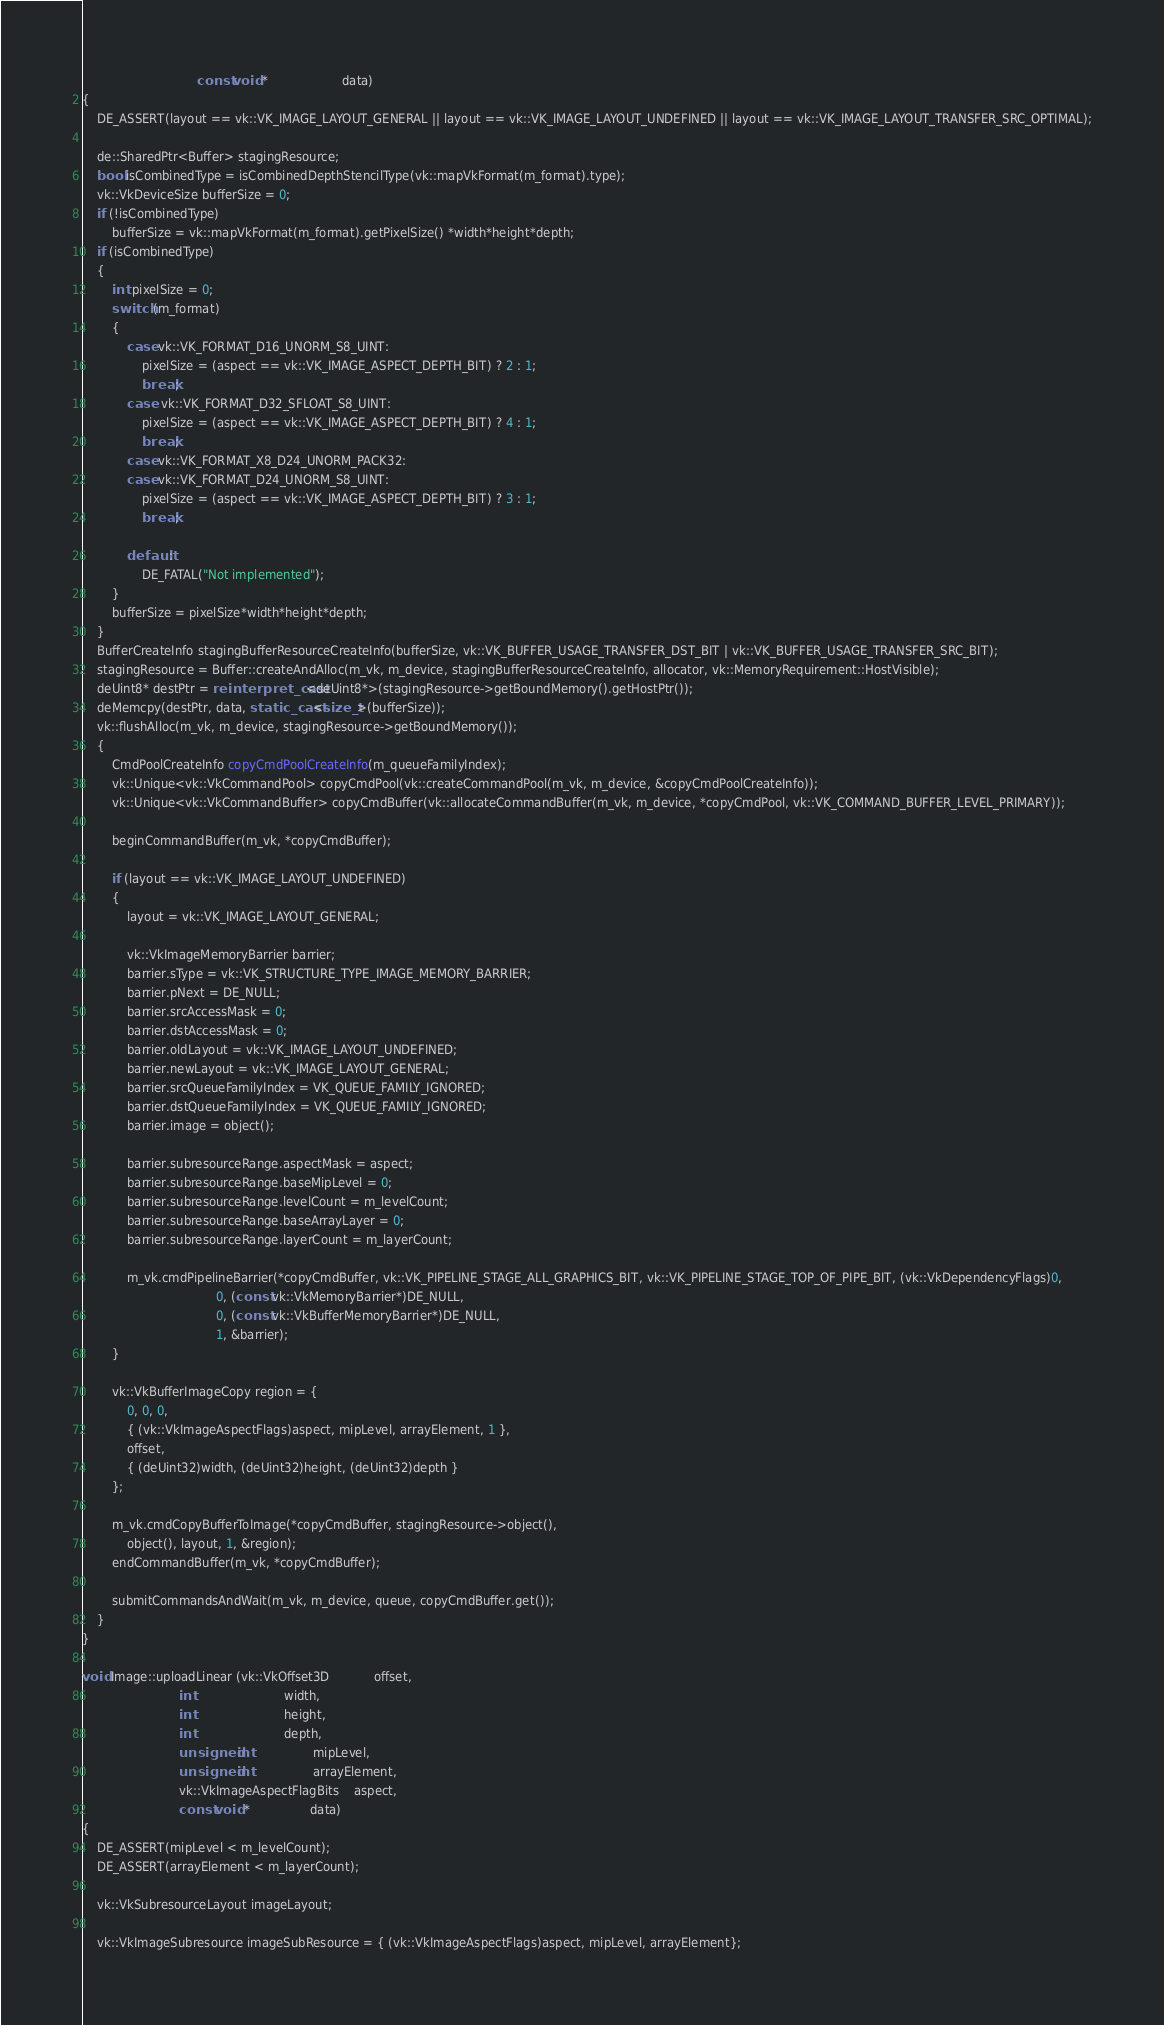<code> <loc_0><loc_0><loc_500><loc_500><_C++_>							   const void *					data)
{
	DE_ASSERT(layout == vk::VK_IMAGE_LAYOUT_GENERAL || layout == vk::VK_IMAGE_LAYOUT_UNDEFINED || layout == vk::VK_IMAGE_LAYOUT_TRANSFER_SRC_OPTIMAL);

	de::SharedPtr<Buffer> stagingResource;
	bool isCombinedType = isCombinedDepthStencilType(vk::mapVkFormat(m_format).type);
	vk::VkDeviceSize bufferSize = 0;
	if (!isCombinedType)
		bufferSize = vk::mapVkFormat(m_format).getPixelSize() *width*height*depth;
	if (isCombinedType)
	{
		int pixelSize = 0;
		switch (m_format)
		{
			case vk::VK_FORMAT_D16_UNORM_S8_UINT:
				pixelSize = (aspect == vk::VK_IMAGE_ASPECT_DEPTH_BIT) ? 2 : 1;
				break;
			case  vk::VK_FORMAT_D32_SFLOAT_S8_UINT:
				pixelSize = (aspect == vk::VK_IMAGE_ASPECT_DEPTH_BIT) ? 4 : 1;
				break;
			case vk::VK_FORMAT_X8_D24_UNORM_PACK32:
			case vk::VK_FORMAT_D24_UNORM_S8_UINT:
				pixelSize = (aspect == vk::VK_IMAGE_ASPECT_DEPTH_BIT) ? 3 : 1;
				break;

			default:
				DE_FATAL("Not implemented");
		}
		bufferSize = pixelSize*width*height*depth;
	}
	BufferCreateInfo stagingBufferResourceCreateInfo(bufferSize, vk::VK_BUFFER_USAGE_TRANSFER_DST_BIT | vk::VK_BUFFER_USAGE_TRANSFER_SRC_BIT);
	stagingResource = Buffer::createAndAlloc(m_vk, m_device, stagingBufferResourceCreateInfo, allocator, vk::MemoryRequirement::HostVisible);
	deUint8* destPtr = reinterpret_cast<deUint8*>(stagingResource->getBoundMemory().getHostPtr());
	deMemcpy(destPtr, data, static_cast<size_t>(bufferSize));
	vk::flushAlloc(m_vk, m_device, stagingResource->getBoundMemory());
	{
		CmdPoolCreateInfo copyCmdPoolCreateInfo(m_queueFamilyIndex);
		vk::Unique<vk::VkCommandPool> copyCmdPool(vk::createCommandPool(m_vk, m_device, &copyCmdPoolCreateInfo));
		vk::Unique<vk::VkCommandBuffer> copyCmdBuffer(vk::allocateCommandBuffer(m_vk, m_device, *copyCmdPool, vk::VK_COMMAND_BUFFER_LEVEL_PRIMARY));

		beginCommandBuffer(m_vk, *copyCmdBuffer);

		if (layout == vk::VK_IMAGE_LAYOUT_UNDEFINED)
		{
			layout = vk::VK_IMAGE_LAYOUT_GENERAL;

			vk::VkImageMemoryBarrier barrier;
			barrier.sType = vk::VK_STRUCTURE_TYPE_IMAGE_MEMORY_BARRIER;
			barrier.pNext = DE_NULL;
			barrier.srcAccessMask = 0;
			barrier.dstAccessMask = 0;
			barrier.oldLayout = vk::VK_IMAGE_LAYOUT_UNDEFINED;
			barrier.newLayout = vk::VK_IMAGE_LAYOUT_GENERAL;
			barrier.srcQueueFamilyIndex = VK_QUEUE_FAMILY_IGNORED;
			barrier.dstQueueFamilyIndex = VK_QUEUE_FAMILY_IGNORED;
			barrier.image = object();

			barrier.subresourceRange.aspectMask = aspect;
			barrier.subresourceRange.baseMipLevel = 0;
			barrier.subresourceRange.levelCount = m_levelCount;
			barrier.subresourceRange.baseArrayLayer = 0;
			barrier.subresourceRange.layerCount = m_layerCount;

			m_vk.cmdPipelineBarrier(*copyCmdBuffer, vk::VK_PIPELINE_STAGE_ALL_GRAPHICS_BIT, vk::VK_PIPELINE_STAGE_TOP_OF_PIPE_BIT, (vk::VkDependencyFlags)0,
									0, (const vk::VkMemoryBarrier*)DE_NULL,
									0, (const vk::VkBufferMemoryBarrier*)DE_NULL,
									1, &barrier);
		}

		vk::VkBufferImageCopy region = {
			0, 0, 0,
			{ (vk::VkImageAspectFlags)aspect, mipLevel, arrayElement, 1 },
			offset,
			{ (deUint32)width, (deUint32)height, (deUint32)depth }
		};

		m_vk.cmdCopyBufferToImage(*copyCmdBuffer, stagingResource->object(),
			object(), layout, 1, &region);
		endCommandBuffer(m_vk, *copyCmdBuffer);

		submitCommandsAndWait(m_vk, m_device, queue, copyCmdBuffer.get());
	}
}

void Image::uploadLinear (vk::VkOffset3D			offset,
						  int						width,
						  int						height,
						  int						depth,
						  unsigned int				mipLevel,
						  unsigned int				arrayElement,
						  vk::VkImageAspectFlagBits	aspect,
						  const void *				data)
{
	DE_ASSERT(mipLevel < m_levelCount);
	DE_ASSERT(arrayElement < m_layerCount);

	vk::VkSubresourceLayout imageLayout;

	vk::VkImageSubresource imageSubResource = { (vk::VkImageAspectFlags)aspect, mipLevel, arrayElement};
</code> 